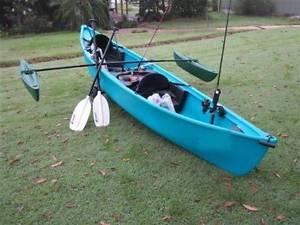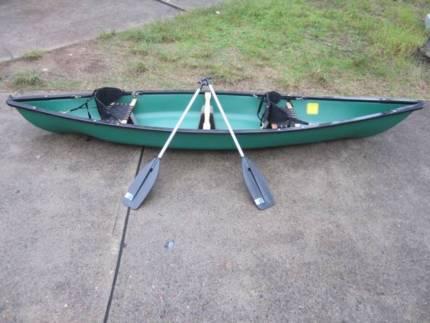The first image is the image on the left, the second image is the image on the right. For the images displayed, is the sentence "All of the canoes and kayaks have oars on them." factually correct? Answer yes or no. Yes. 